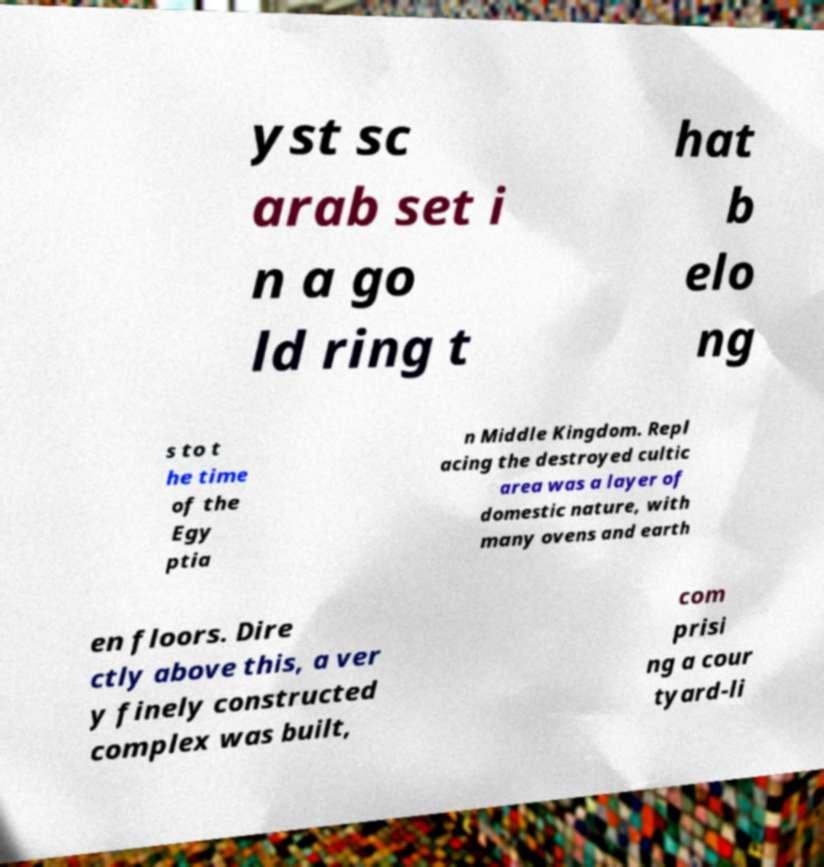Could you extract and type out the text from this image? yst sc arab set i n a go ld ring t hat b elo ng s to t he time of the Egy ptia n Middle Kingdom. Repl acing the destroyed cultic area was a layer of domestic nature, with many ovens and earth en floors. Dire ctly above this, a ver y finely constructed complex was built, com prisi ng a cour tyard-li 